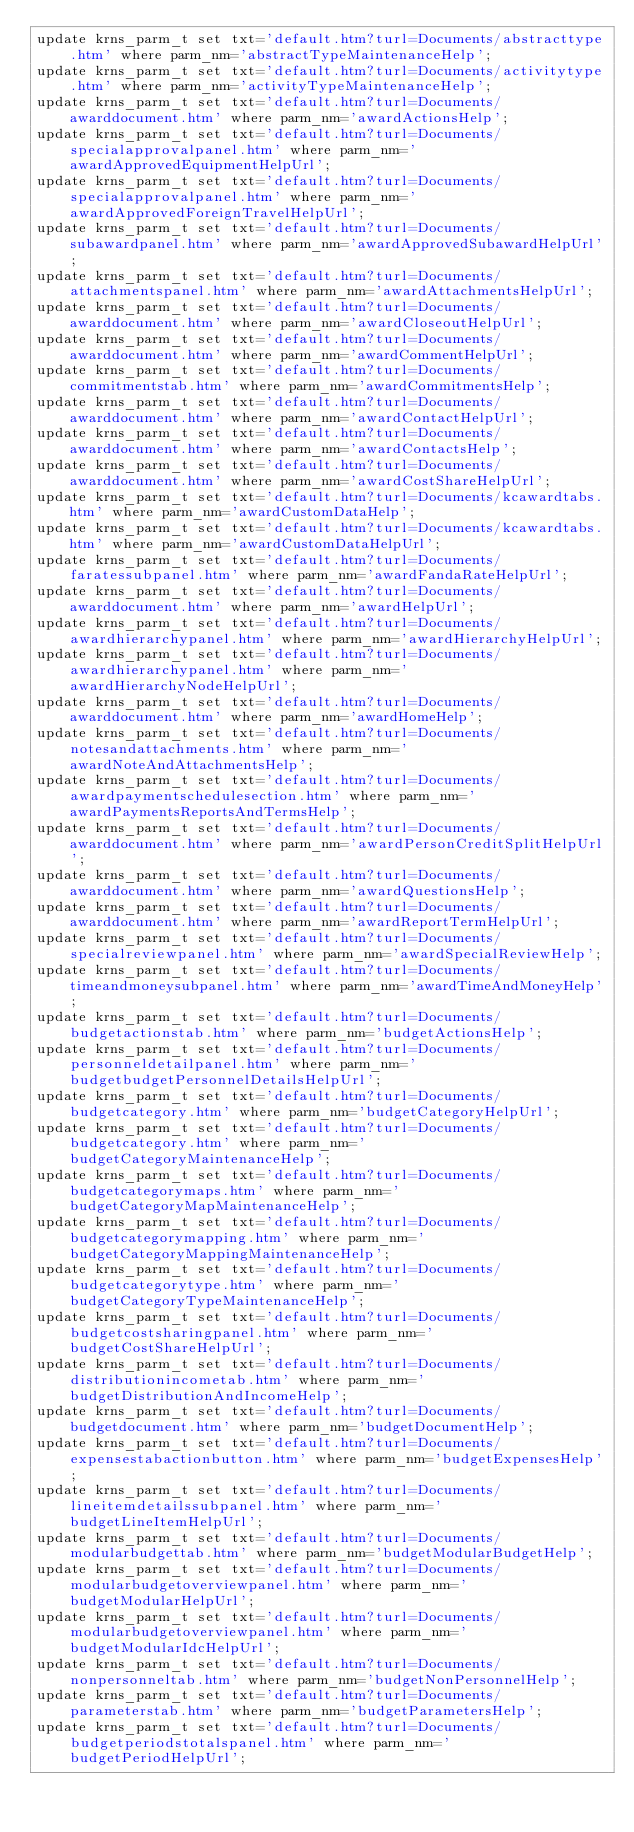Convert code to text. <code><loc_0><loc_0><loc_500><loc_500><_SQL_>update krns_parm_t set txt='default.htm?turl=Documents/abstracttype.htm' where parm_nm='abstractTypeMaintenanceHelp';
update krns_parm_t set txt='default.htm?turl=Documents/activitytype.htm' where parm_nm='activityTypeMaintenanceHelp';
update krns_parm_t set txt='default.htm?turl=Documents/awarddocument.htm' where parm_nm='awardActionsHelp';
update krns_parm_t set txt='default.htm?turl=Documents/specialapprovalpanel.htm' where parm_nm='awardApprovedEquipmentHelpUrl';
update krns_parm_t set txt='default.htm?turl=Documents/specialapprovalpanel.htm' where parm_nm='awardApprovedForeignTravelHelpUrl';
update krns_parm_t set txt='default.htm?turl=Documents/subawardpanel.htm' where parm_nm='awardApprovedSubawardHelpUrl';
update krns_parm_t set txt='default.htm?turl=Documents/attachmentspanel.htm' where parm_nm='awardAttachmentsHelpUrl';
update krns_parm_t set txt='default.htm?turl=Documents/awarddocument.htm' where parm_nm='awardCloseoutHelpUrl';
update krns_parm_t set txt='default.htm?turl=Documents/awarddocument.htm' where parm_nm='awardCommentHelpUrl';
update krns_parm_t set txt='default.htm?turl=Documents/commitmentstab.htm' where parm_nm='awardCommitmentsHelp';
update krns_parm_t set txt='default.htm?turl=Documents/awarddocument.htm' where parm_nm='awardContactHelpUrl';
update krns_parm_t set txt='default.htm?turl=Documents/awarddocument.htm' where parm_nm='awardContactsHelp';
update krns_parm_t set txt='default.htm?turl=Documents/awarddocument.htm' where parm_nm='awardCostShareHelpUrl';
update krns_parm_t set txt='default.htm?turl=Documents/kcawardtabs.htm' where parm_nm='awardCustomDataHelp';
update krns_parm_t set txt='default.htm?turl=Documents/kcawardtabs.htm' where parm_nm='awardCustomDataHelpUrl';
update krns_parm_t set txt='default.htm?turl=Documents/faratessubpanel.htm' where parm_nm='awardFandaRateHelpUrl';
update krns_parm_t set txt='default.htm?turl=Documents/awarddocument.htm' where parm_nm='awardHelpUrl';
update krns_parm_t set txt='default.htm?turl=Documents/awardhierarchypanel.htm' where parm_nm='awardHierarchyHelpUrl';
update krns_parm_t set txt='default.htm?turl=Documents/awardhierarchypanel.htm' where parm_nm='awardHierarchyNodeHelpUrl';
update krns_parm_t set txt='default.htm?turl=Documents/awarddocument.htm' where parm_nm='awardHomeHelp';
update krns_parm_t set txt='default.htm?turl=Documents/notesandattachments.htm' where parm_nm='awardNoteAndAttachmentsHelp';
update krns_parm_t set txt='default.htm?turl=Documents/awardpaymentschedulesection.htm' where parm_nm='awardPaymentsReportsAndTermsHelp';
update krns_parm_t set txt='default.htm?turl=Documents/awarddocument.htm' where parm_nm='awardPersonCreditSplitHelpUrl';
update krns_parm_t set txt='default.htm?turl=Documents/awarddocument.htm' where parm_nm='awardQuestionsHelp';
update krns_parm_t set txt='default.htm?turl=Documents/awarddocument.htm' where parm_nm='awardReportTermHelpUrl';
update krns_parm_t set txt='default.htm?turl=Documents/specialreviewpanel.htm' where parm_nm='awardSpecialReviewHelp';
update krns_parm_t set txt='default.htm?turl=Documents/timeandmoneysubpanel.htm' where parm_nm='awardTimeAndMoneyHelp';
update krns_parm_t set txt='default.htm?turl=Documents/budgetactionstab.htm' where parm_nm='budgetActionsHelp';
update krns_parm_t set txt='default.htm?turl=Documents/personneldetailpanel.htm' where parm_nm='budgetbudgetPersonnelDetailsHelpUrl';
update krns_parm_t set txt='default.htm?turl=Documents/budgetcategory.htm' where parm_nm='budgetCategoryHelpUrl';
update krns_parm_t set txt='default.htm?turl=Documents/budgetcategory.htm' where parm_nm='budgetCategoryMaintenanceHelp';
update krns_parm_t set txt='default.htm?turl=Documents/budgetcategorymaps.htm' where parm_nm='budgetCategoryMapMaintenanceHelp';
update krns_parm_t set txt='default.htm?turl=Documents/budgetcategorymapping.htm' where parm_nm='budgetCategoryMappingMaintenanceHelp';
update krns_parm_t set txt='default.htm?turl=Documents/budgetcategorytype.htm' where parm_nm='budgetCategoryTypeMaintenanceHelp';
update krns_parm_t set txt='default.htm?turl=Documents/budgetcostsharingpanel.htm' where parm_nm='budgetCostShareHelpUrl';
update krns_parm_t set txt='default.htm?turl=Documents/distributionincometab.htm' where parm_nm='budgetDistributionAndIncomeHelp';
update krns_parm_t set txt='default.htm?turl=Documents/budgetdocument.htm' where parm_nm='budgetDocumentHelp';
update krns_parm_t set txt='default.htm?turl=Documents/expensestabactionbutton.htm' where parm_nm='budgetExpensesHelp';
update krns_parm_t set txt='default.htm?turl=Documents/lineitemdetailssubpanel.htm' where parm_nm='budgetLineItemHelpUrl';
update krns_parm_t set txt='default.htm?turl=Documents/modularbudgettab.htm' where parm_nm='budgetModularBudgetHelp';
update krns_parm_t set txt='default.htm?turl=Documents/modularbudgetoverviewpanel.htm' where parm_nm='budgetModularHelpUrl';
update krns_parm_t set txt='default.htm?turl=Documents/modularbudgetoverviewpanel.htm' where parm_nm='budgetModularIdcHelpUrl';
update krns_parm_t set txt='default.htm?turl=Documents/nonpersonneltab.htm' where parm_nm='budgetNonPersonnelHelp';
update krns_parm_t set txt='default.htm?turl=Documents/parameterstab.htm' where parm_nm='budgetParametersHelp';
update krns_parm_t set txt='default.htm?turl=Documents/budgetperiodstotalspanel.htm' where parm_nm='budgetPeriodHelpUrl';</code> 